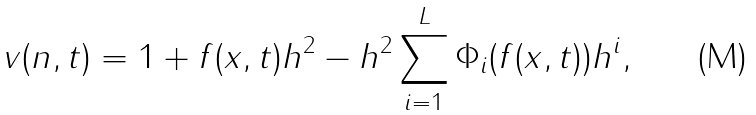<formula> <loc_0><loc_0><loc_500><loc_500>v ( n , t ) = 1 + f ( x , t ) h ^ { 2 } - h ^ { 2 } \sum _ { i = 1 } ^ { L } \Phi _ { i } ( f ( x , t ) ) h ^ { i } ,</formula> 